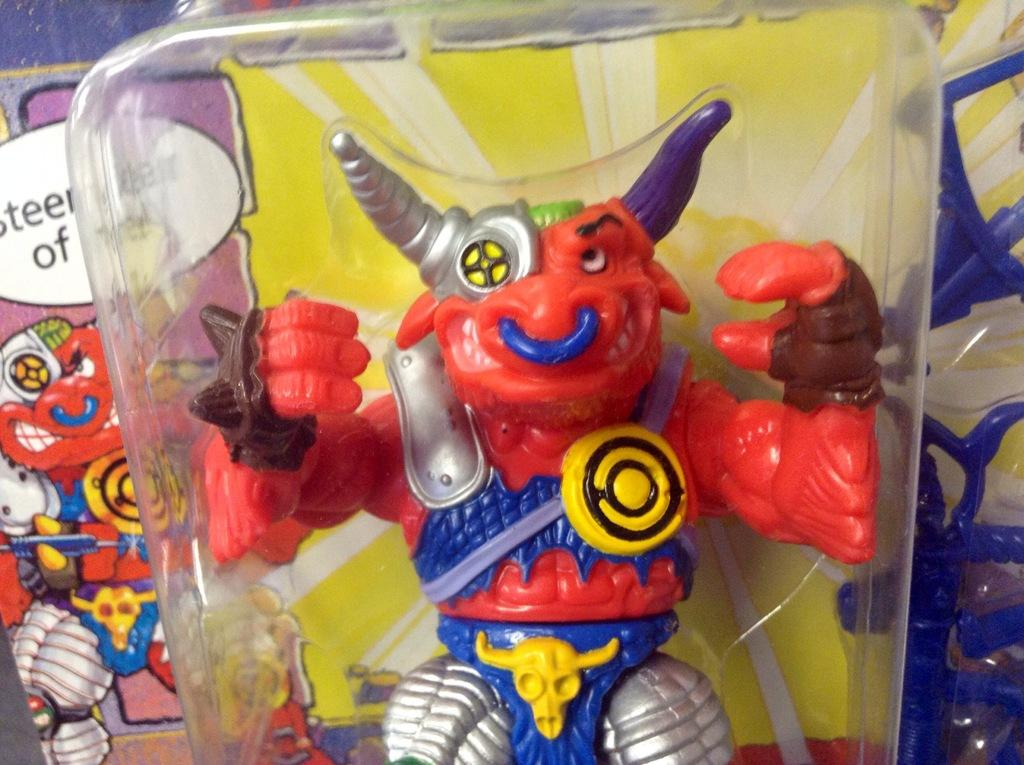What is inside the box in the image? There is a toy in a box. What can be seen in the background of the image? There are colorful toys visible at the back of the image. What does the mom say about the toys in the image? There is no mention of a mom or any dialogue in the image, so it cannot be determined what she might say about the toys. 